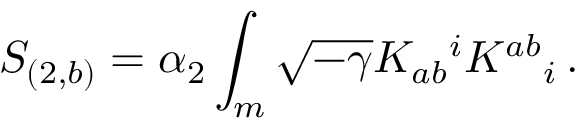<formula> <loc_0><loc_0><loc_500><loc_500>S _ { ( 2 , b ) } = \alpha _ { 2 } \int _ { m } \sqrt { - \gamma } K _ { a b ^ { i } K ^ { a b _ { i } \, .</formula> 